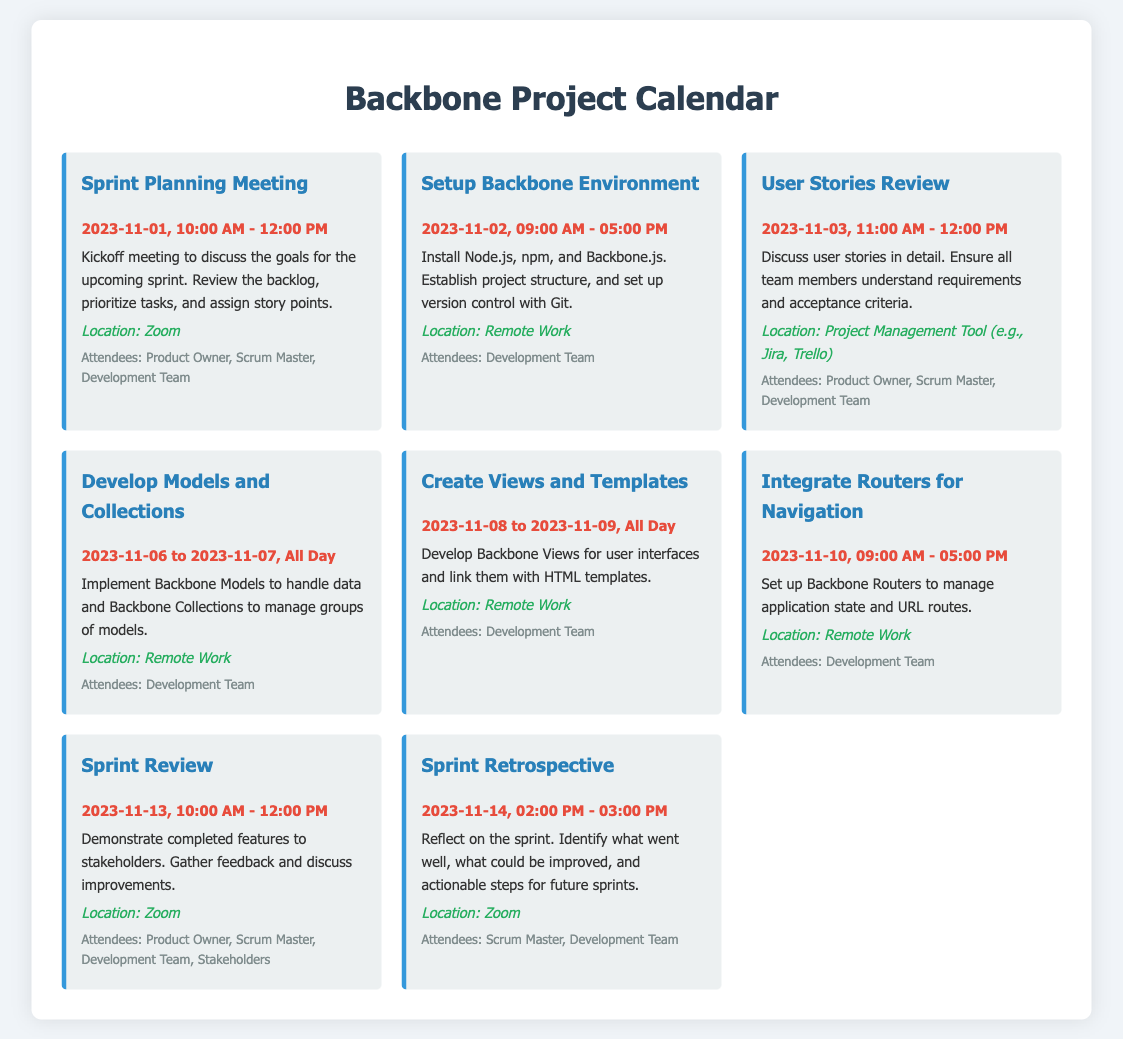What is the date and time of the Sprint Planning Meeting? The meeting is scheduled for 2023-11-01, from 10:00 AM to 12:00 PM.
Answer: 2023-11-01, 10:00 AM - 12:00 PM Who are the attendees for the Sprint Review? The attendees include the Product Owner, Scrum Master, Development Team, and Stakeholders.
Answer: Product Owner, Scrum Master, Development Team, Stakeholders What task is scheduled for 2023-11-10? On this date, the task is to integrate routers for navigation.
Answer: Integrate Routers for Navigation How many days are allocated for developing models and collections? The task is scheduled for 2 days, from 2023-11-06 to 2023-11-07.
Answer: 2 days What is the location for the User Stories Review? The location for this review is a project management tool, like Jira or Trello.
Answer: Project Management Tool (e.g., Jira, Trello) What time does the Sprint Retrospective begin? The Sprint Retrospective starts at 2:00 PM.
Answer: 2:00 PM What is the main goal of the Sprint Planning Meeting? The goal is to discuss upcoming sprint goals, review backlog, and prioritize tasks.
Answer: Discuss the goals for the upcoming sprint Which event is immediately after the Setup Backbone Environment? The User Stories Review follows the Setup Backbone Environment.
Answer: User Stories Review 